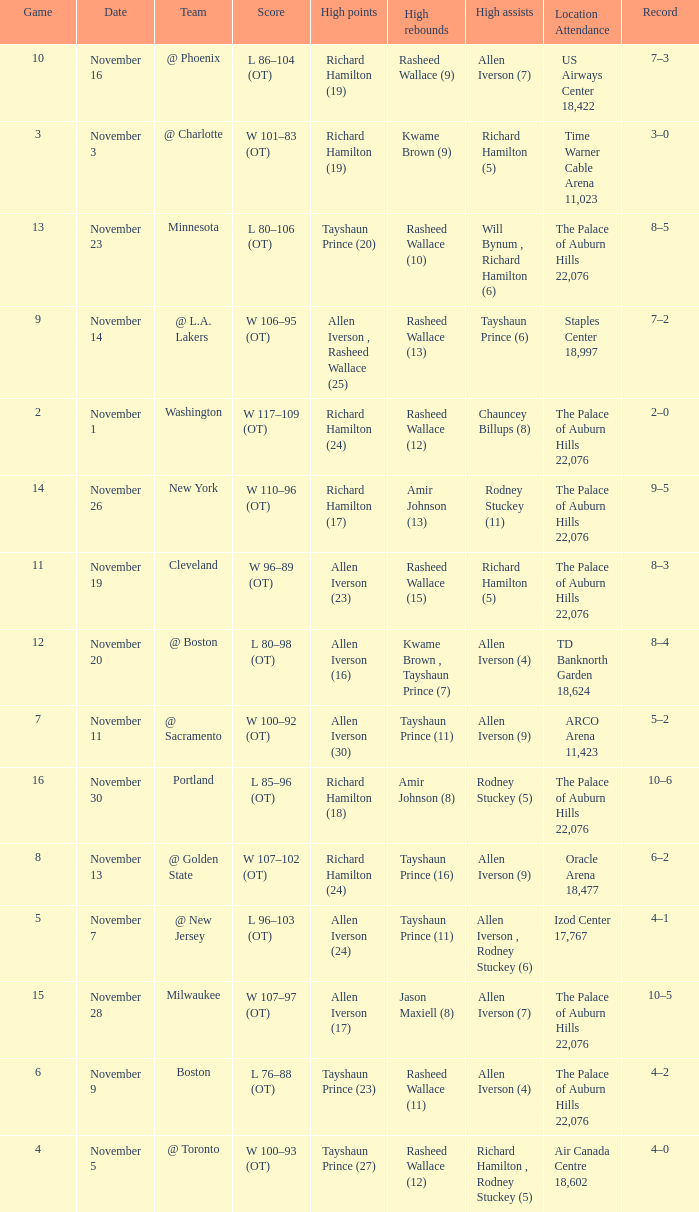Can you give me this table as a dict? {'header': ['Game', 'Date', 'Team', 'Score', 'High points', 'High rebounds', 'High assists', 'Location Attendance', 'Record'], 'rows': [['10', 'November 16', '@ Phoenix', 'L 86–104 (OT)', 'Richard Hamilton (19)', 'Rasheed Wallace (9)', 'Allen Iverson (7)', 'US Airways Center 18,422', '7–3'], ['3', 'November 3', '@ Charlotte', 'W 101–83 (OT)', 'Richard Hamilton (19)', 'Kwame Brown (9)', 'Richard Hamilton (5)', 'Time Warner Cable Arena 11,023', '3–0'], ['13', 'November 23', 'Minnesota', 'L 80–106 (OT)', 'Tayshaun Prince (20)', 'Rasheed Wallace (10)', 'Will Bynum , Richard Hamilton (6)', 'The Palace of Auburn Hills 22,076', '8–5'], ['9', 'November 14', '@ L.A. Lakers', 'W 106–95 (OT)', 'Allen Iverson , Rasheed Wallace (25)', 'Rasheed Wallace (13)', 'Tayshaun Prince (6)', 'Staples Center 18,997', '7–2'], ['2', 'November 1', 'Washington', 'W 117–109 (OT)', 'Richard Hamilton (24)', 'Rasheed Wallace (12)', 'Chauncey Billups (8)', 'The Palace of Auburn Hills 22,076', '2–0'], ['14', 'November 26', 'New York', 'W 110–96 (OT)', 'Richard Hamilton (17)', 'Amir Johnson (13)', 'Rodney Stuckey (11)', 'The Palace of Auburn Hills 22,076', '9–5'], ['11', 'November 19', 'Cleveland', 'W 96–89 (OT)', 'Allen Iverson (23)', 'Rasheed Wallace (15)', 'Richard Hamilton (5)', 'The Palace of Auburn Hills 22,076', '8–3'], ['12', 'November 20', '@ Boston', 'L 80–98 (OT)', 'Allen Iverson (16)', 'Kwame Brown , Tayshaun Prince (7)', 'Allen Iverson (4)', 'TD Banknorth Garden 18,624', '8–4'], ['7', 'November 11', '@ Sacramento', 'W 100–92 (OT)', 'Allen Iverson (30)', 'Tayshaun Prince (11)', 'Allen Iverson (9)', 'ARCO Arena 11,423', '5–2'], ['16', 'November 30', 'Portland', 'L 85–96 (OT)', 'Richard Hamilton (18)', 'Amir Johnson (8)', 'Rodney Stuckey (5)', 'The Palace of Auburn Hills 22,076', '10–6'], ['8', 'November 13', '@ Golden State', 'W 107–102 (OT)', 'Richard Hamilton (24)', 'Tayshaun Prince (16)', 'Allen Iverson (9)', 'Oracle Arena 18,477', '6–2'], ['5', 'November 7', '@ New Jersey', 'L 96–103 (OT)', 'Allen Iverson (24)', 'Tayshaun Prince (11)', 'Allen Iverson , Rodney Stuckey (6)', 'Izod Center 17,767', '4–1'], ['15', 'November 28', 'Milwaukee', 'W 107–97 (OT)', 'Allen Iverson (17)', 'Jason Maxiell (8)', 'Allen Iverson (7)', 'The Palace of Auburn Hills 22,076', '10–5'], ['6', 'November 9', 'Boston', 'L 76–88 (OT)', 'Tayshaun Prince (23)', 'Rasheed Wallace (11)', 'Allen Iverson (4)', 'The Palace of Auburn Hills 22,076', '4–2'], ['4', 'November 5', '@ Toronto', 'W 100–93 (OT)', 'Tayshaun Prince (27)', 'Rasheed Wallace (12)', 'Richard Hamilton , Rodney Stuckey (5)', 'Air Canada Centre 18,602', '4–0']]} What is the average Game, when Team is "Milwaukee"? 15.0. 